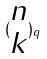<formula> <loc_0><loc_0><loc_500><loc_500>( \begin{matrix} n \\ k \end{matrix} ) _ { q }</formula> 